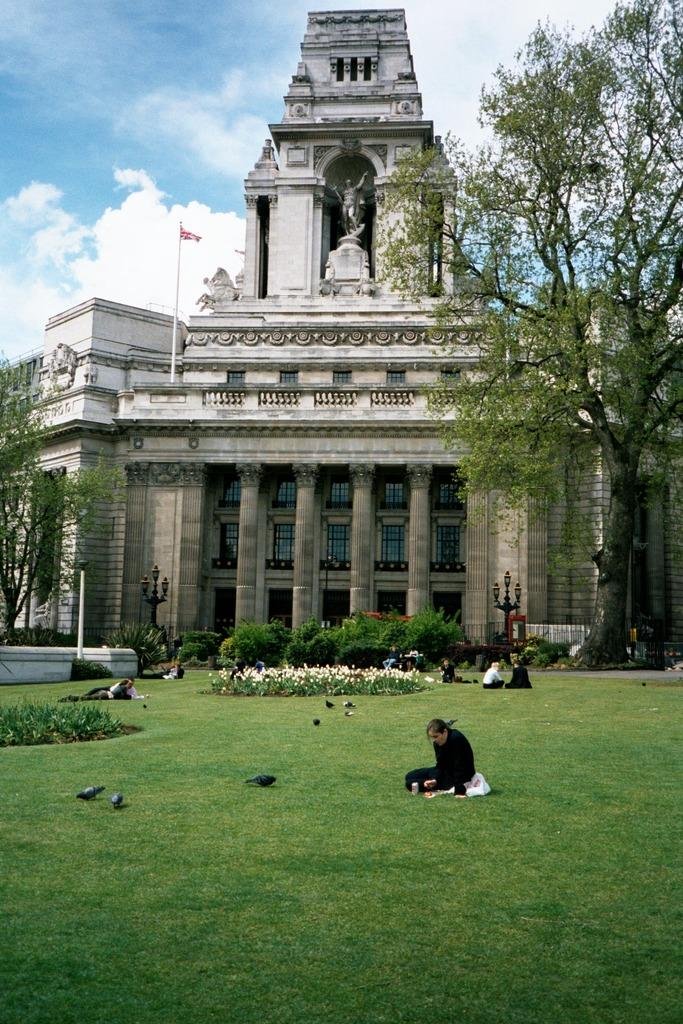What can be seen in the image? There are people, birds on the grass, a planter, light poles, trees, a building, a flag, and a statue in the image. What is the background of the image? The sky with clouds is visible in the background. What type of structure is present in the image? There is a building in the image. What is the purpose of the flag in the image? The flag's purpose cannot be determined from the image alone, but it may represent a country, organization, or event. What type of salt is being used to season the birds in the image? There is no salt or seasoning visible in the image, and the birds are not being prepared for consumption. How does the meeting between the people in the image affect the statue's appearance? There is no meeting or interaction between the people in the image that would affect the statue's appearance. 